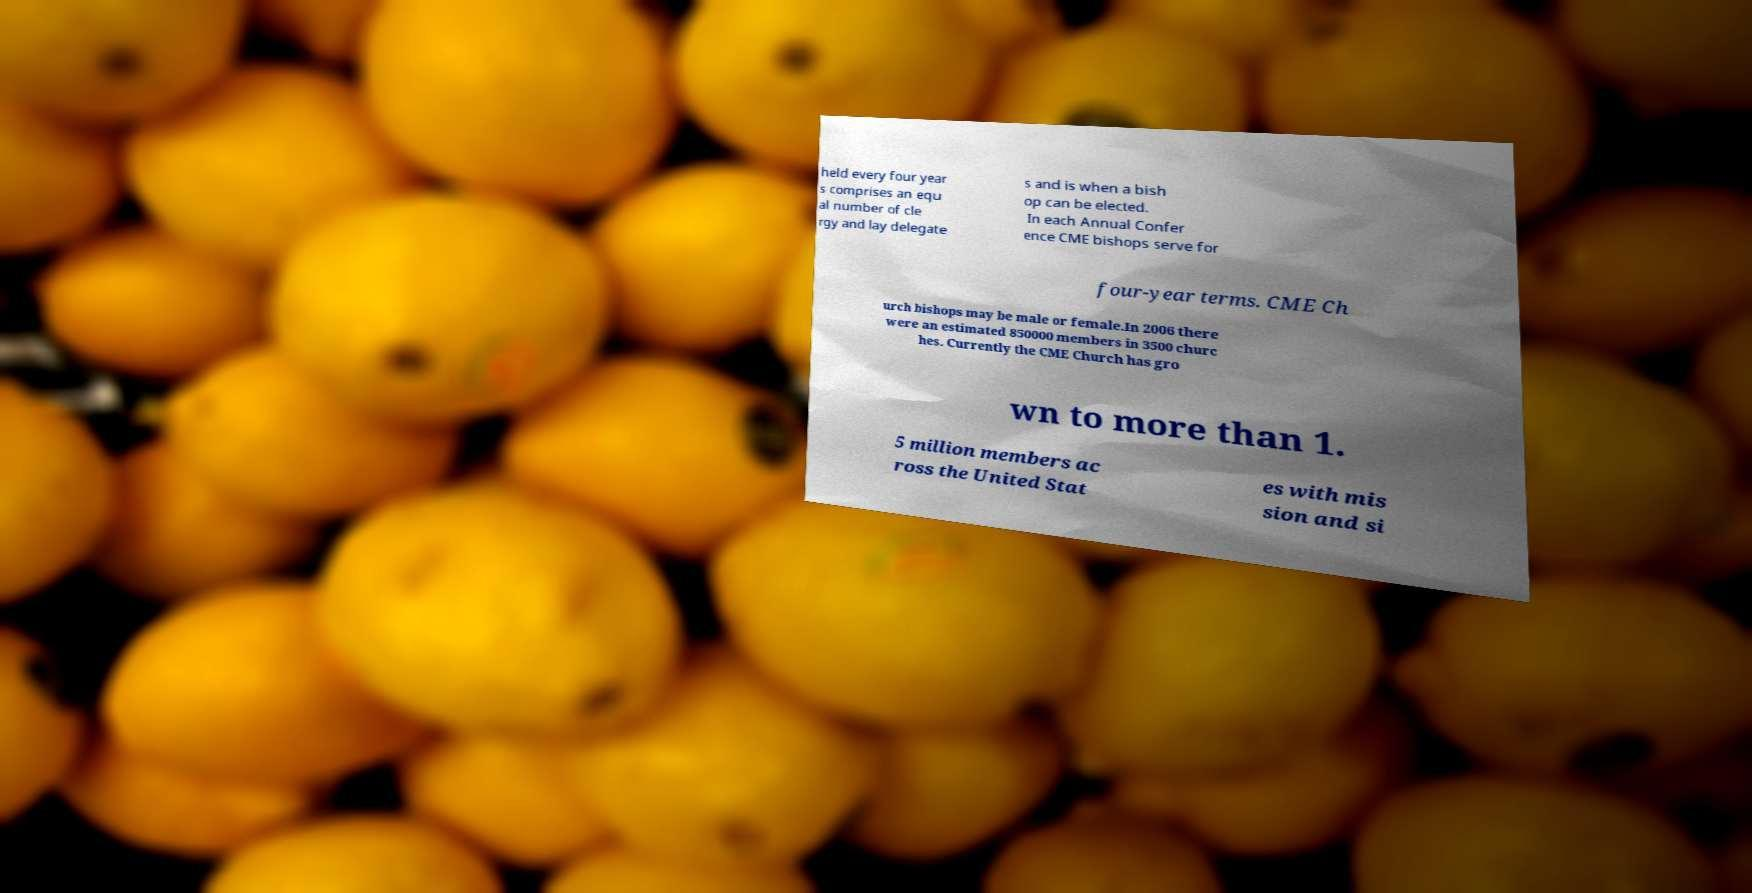For documentation purposes, I need the text within this image transcribed. Could you provide that? held every four year s comprises an equ al number of cle rgy and lay delegate s and is when a bish op can be elected. In each Annual Confer ence CME bishops serve for four-year terms. CME Ch urch bishops may be male or female.In 2006 there were an estimated 850000 members in 3500 churc hes. Currently the CME Church has gro wn to more than 1. 5 million members ac ross the United Stat es with mis sion and si 